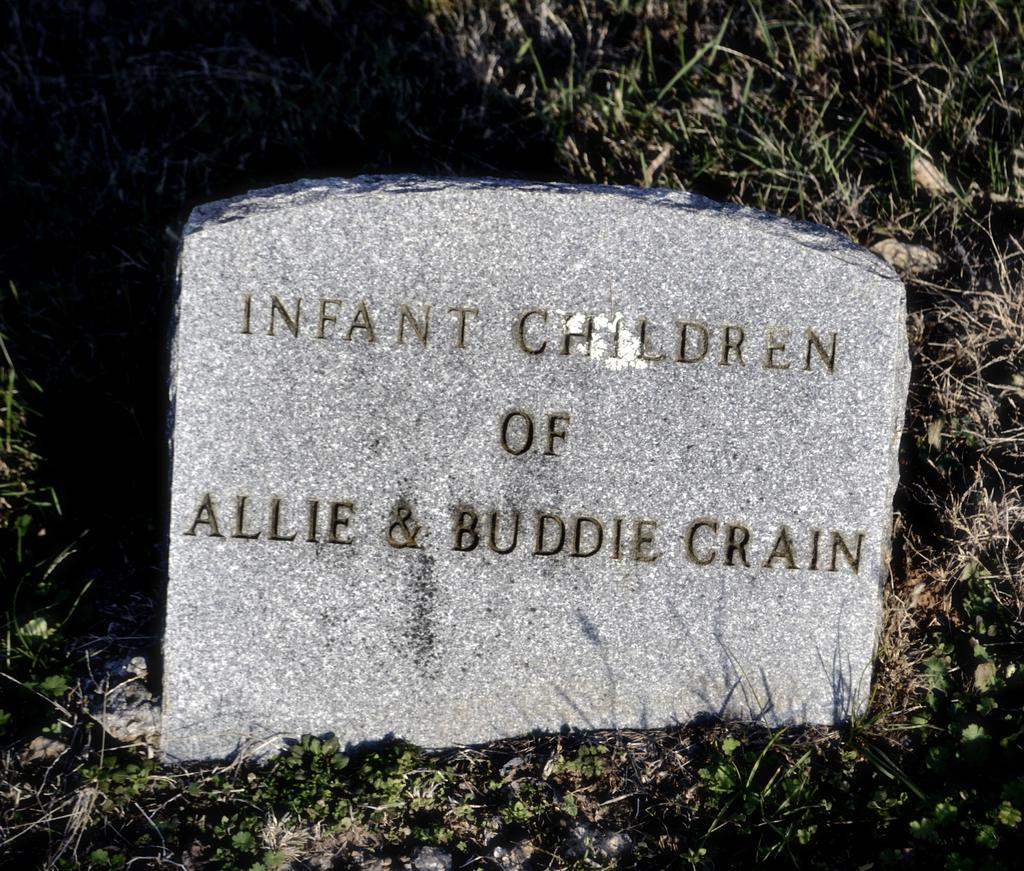What is the main subject in the center of the image? There is a stone in the center of the image. Are there any markings or text on the stone? Yes, the stone has some text on it. What type of vegetation is visible at the bottom of the image? There is grass at the bottom of the image. What type of whip can be seen in the image? There is no whip present in the image. How does the stone crush the neck in the image? The stone does not crush the neck in the image; it is a stationary object with text on it. 